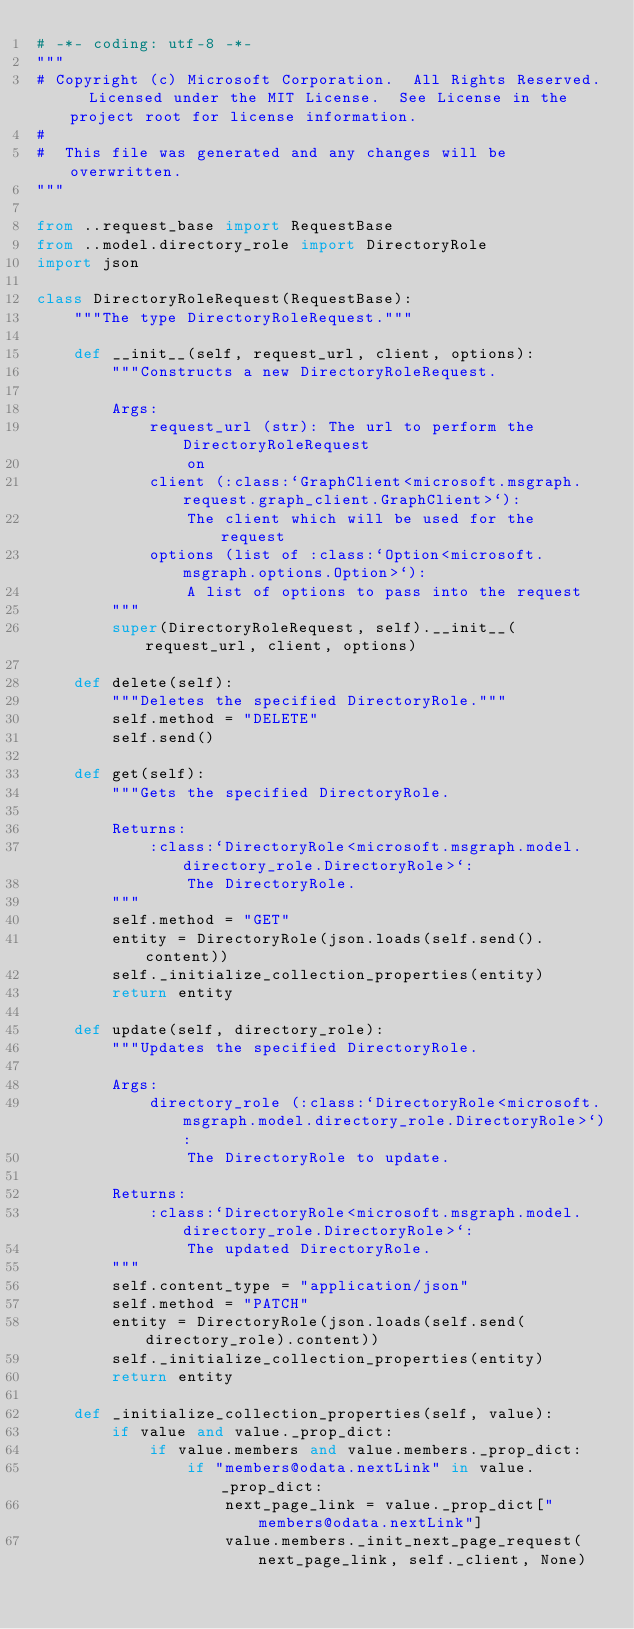<code> <loc_0><loc_0><loc_500><loc_500><_Python_># -*- coding: utf-8 -*- 
"""
# Copyright (c) Microsoft Corporation.  All Rights Reserved.  Licensed under the MIT License.  See License in the project root for license information.
# 
#  This file was generated and any changes will be overwritten.
"""

from ..request_base import RequestBase
from ..model.directory_role import DirectoryRole
import json

class DirectoryRoleRequest(RequestBase):
    """The type DirectoryRoleRequest."""
    
    def __init__(self, request_url, client, options):
        """Constructs a new DirectoryRoleRequest.

        Args:
            request_url (str): The url to perform the DirectoryRoleRequest
                on
            client (:class:`GraphClient<microsoft.msgraph.request.graph_client.GraphClient>`):
                The client which will be used for the request
            options (list of :class:`Option<microsoft.msgraph.options.Option>`):
                A list of options to pass into the request
        """
        super(DirectoryRoleRequest, self).__init__(request_url, client, options)

    def delete(self):
        """Deletes the specified DirectoryRole."""
        self.method = "DELETE"
        self.send()

    def get(self):
        """Gets the specified DirectoryRole.
        
        Returns:
            :class:`DirectoryRole<microsoft.msgraph.model.directory_role.DirectoryRole>`:
                The DirectoryRole.
        """
        self.method = "GET"
        entity = DirectoryRole(json.loads(self.send().content))
        self._initialize_collection_properties(entity)
        return entity

    def update(self, directory_role):
        """Updates the specified DirectoryRole.
        
        Args:
            directory_role (:class:`DirectoryRole<microsoft.msgraph.model.directory_role.DirectoryRole>`):
                The DirectoryRole to update.

        Returns:
            :class:`DirectoryRole<microsoft.msgraph.model.directory_role.DirectoryRole>`:
                The updated DirectoryRole.
        """
        self.content_type = "application/json"
        self.method = "PATCH"
        entity = DirectoryRole(json.loads(self.send(directory_role).content))
        self._initialize_collection_properties(entity)
        return entity

    def _initialize_collection_properties(self, value):
        if value and value._prop_dict:
            if value.members and value.members._prop_dict:
                if "members@odata.nextLink" in value._prop_dict:
                    next_page_link = value._prop_dict["members@odata.nextLink"]
                    value.members._init_next_page_request(next_page_link, self._client, None)
</code> 